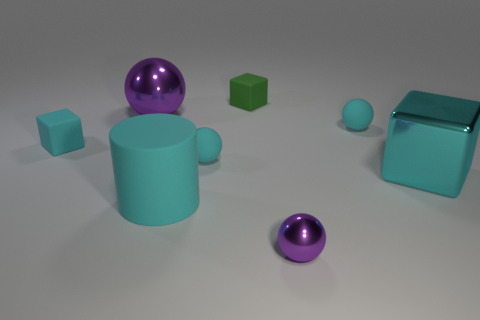The small metallic thing is what color?
Your answer should be compact. Purple. Are there any other things that are the same shape as the large purple metal thing?
Your answer should be very brief. Yes. There is a large shiny object that is the same shape as the small metallic thing; what color is it?
Give a very brief answer. Purple. Does the big cyan matte object have the same shape as the small purple metallic thing?
Give a very brief answer. No. How many cylinders are cyan shiny objects or yellow rubber objects?
Offer a terse response. 0. What is the color of the tiny object that is the same material as the big cube?
Give a very brief answer. Purple. Do the matte thing on the left side of the cyan rubber cylinder and the cylinder have the same size?
Keep it short and to the point. No. Is the big cyan cylinder made of the same material as the ball that is in front of the big cyan cube?
Ensure brevity in your answer.  No. There is a tiny sphere behind the small cyan matte cube; what color is it?
Offer a very short reply. Cyan. Is there a tiny purple shiny ball that is behind the green block behind the small purple shiny ball?
Provide a short and direct response. No. 